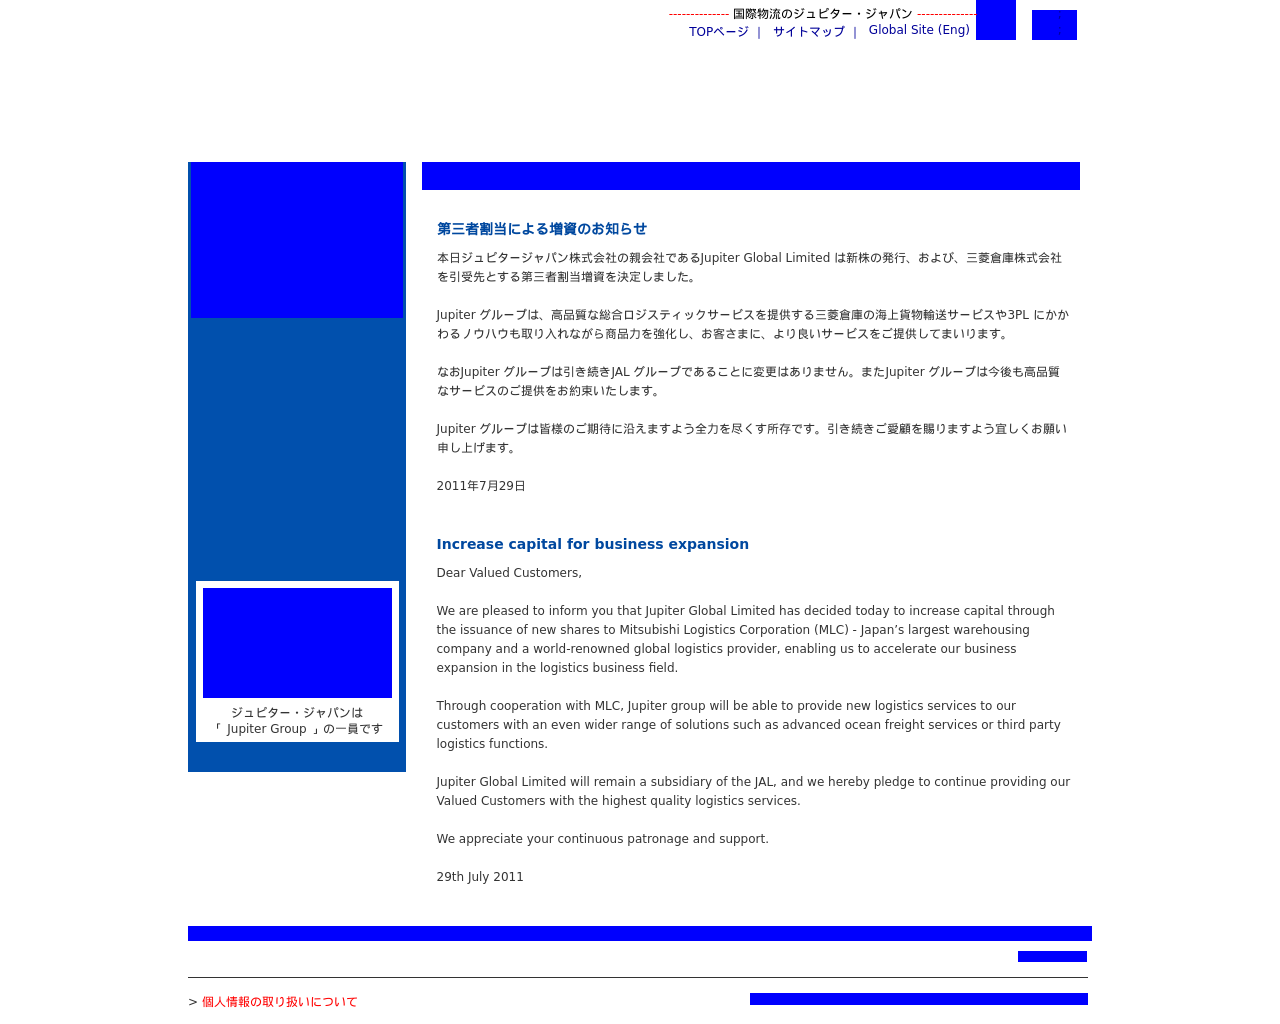Could you detail the process for assembling this website using HTML? To assemble a website like the one in the image, you would start with an HTML structure defining the layout. Utilizing divs for various sections such as header, navigation, main content, and footer, you can efficiently organize content. CSS would control the presentation details like font characteristics and layout dimensions. For dynamic elements or any user interaction, JavaScript might be employed to enhance user experience. By organizing content into semantic HTML tags and linking corresponding CSS for styling and JavaScript for functionality, the assembly of such a website from the ground up ensures a smooth and efficient site operation. 